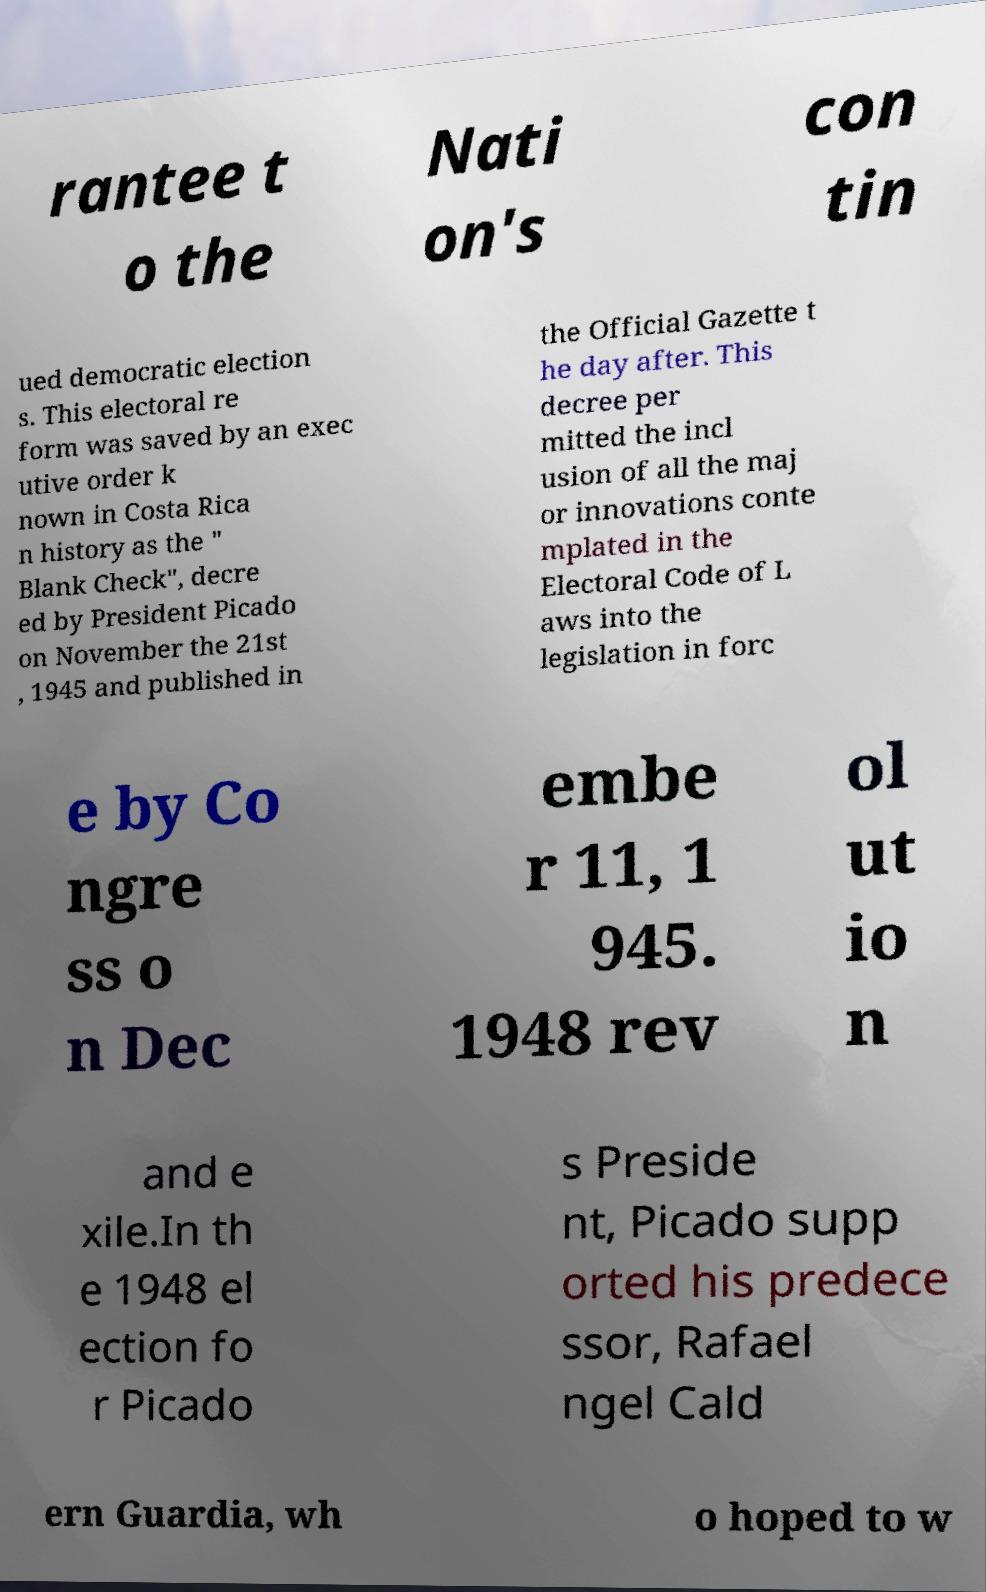I need the written content from this picture converted into text. Can you do that? rantee t o the Nati on's con tin ued democratic election s. This electoral re form was saved by an exec utive order k nown in Costa Rica n history as the " Blank Check", decre ed by President Picado on November the 21st , 1945 and published in the Official Gazette t he day after. This decree per mitted the incl usion of all the maj or innovations conte mplated in the Electoral Code of L aws into the legislation in forc e by Co ngre ss o n Dec embe r 11, 1 945. 1948 rev ol ut io n and e xile.In th e 1948 el ection fo r Picado s Preside nt, Picado supp orted his predece ssor, Rafael ngel Cald ern Guardia, wh o hoped to w 